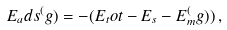<formula> <loc_0><loc_0><loc_500><loc_500>E _ { a } d s ^ { ( } g ) = - ( E _ { t } o t - E _ { s } - E _ { m } ^ { ( } g ) ) \, ,</formula> 